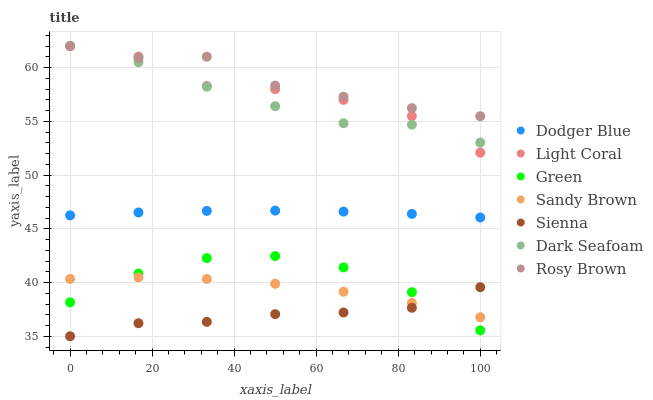Does Sienna have the minimum area under the curve?
Answer yes or no. Yes. Does Rosy Brown have the maximum area under the curve?
Answer yes or no. Yes. Does Light Coral have the minimum area under the curve?
Answer yes or no. No. Does Light Coral have the maximum area under the curve?
Answer yes or no. No. Is Dodger Blue the smoothest?
Answer yes or no. Yes. Is Light Coral the roughest?
Answer yes or no. Yes. Is Rosy Brown the smoothest?
Answer yes or no. No. Is Rosy Brown the roughest?
Answer yes or no. No. Does Sienna have the lowest value?
Answer yes or no. Yes. Does Light Coral have the lowest value?
Answer yes or no. No. Does Dark Seafoam have the highest value?
Answer yes or no. Yes. Does Green have the highest value?
Answer yes or no. No. Is Sandy Brown less than Rosy Brown?
Answer yes or no. Yes. Is Dodger Blue greater than Green?
Answer yes or no. Yes. Does Light Coral intersect Rosy Brown?
Answer yes or no. Yes. Is Light Coral less than Rosy Brown?
Answer yes or no. No. Is Light Coral greater than Rosy Brown?
Answer yes or no. No. Does Sandy Brown intersect Rosy Brown?
Answer yes or no. No. 